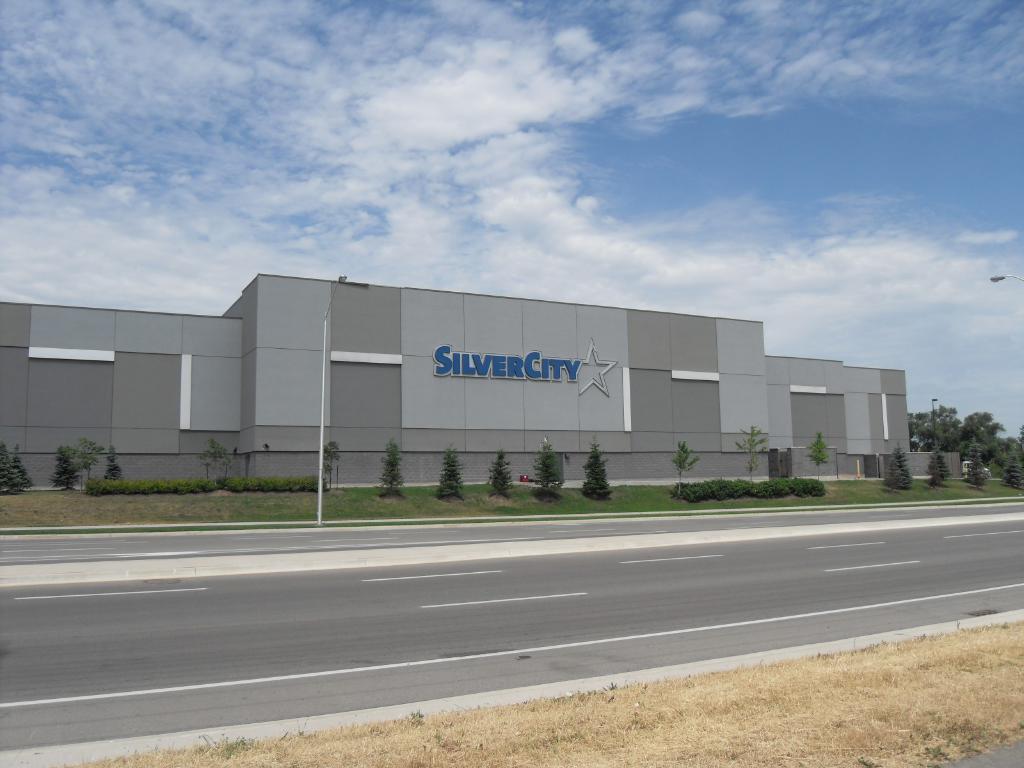Could you give a brief overview of what you see in this image? In the picture I can see a building which has a led board attached on it. I can also see trees, street lights and the grass. In the background I can see the sky. 